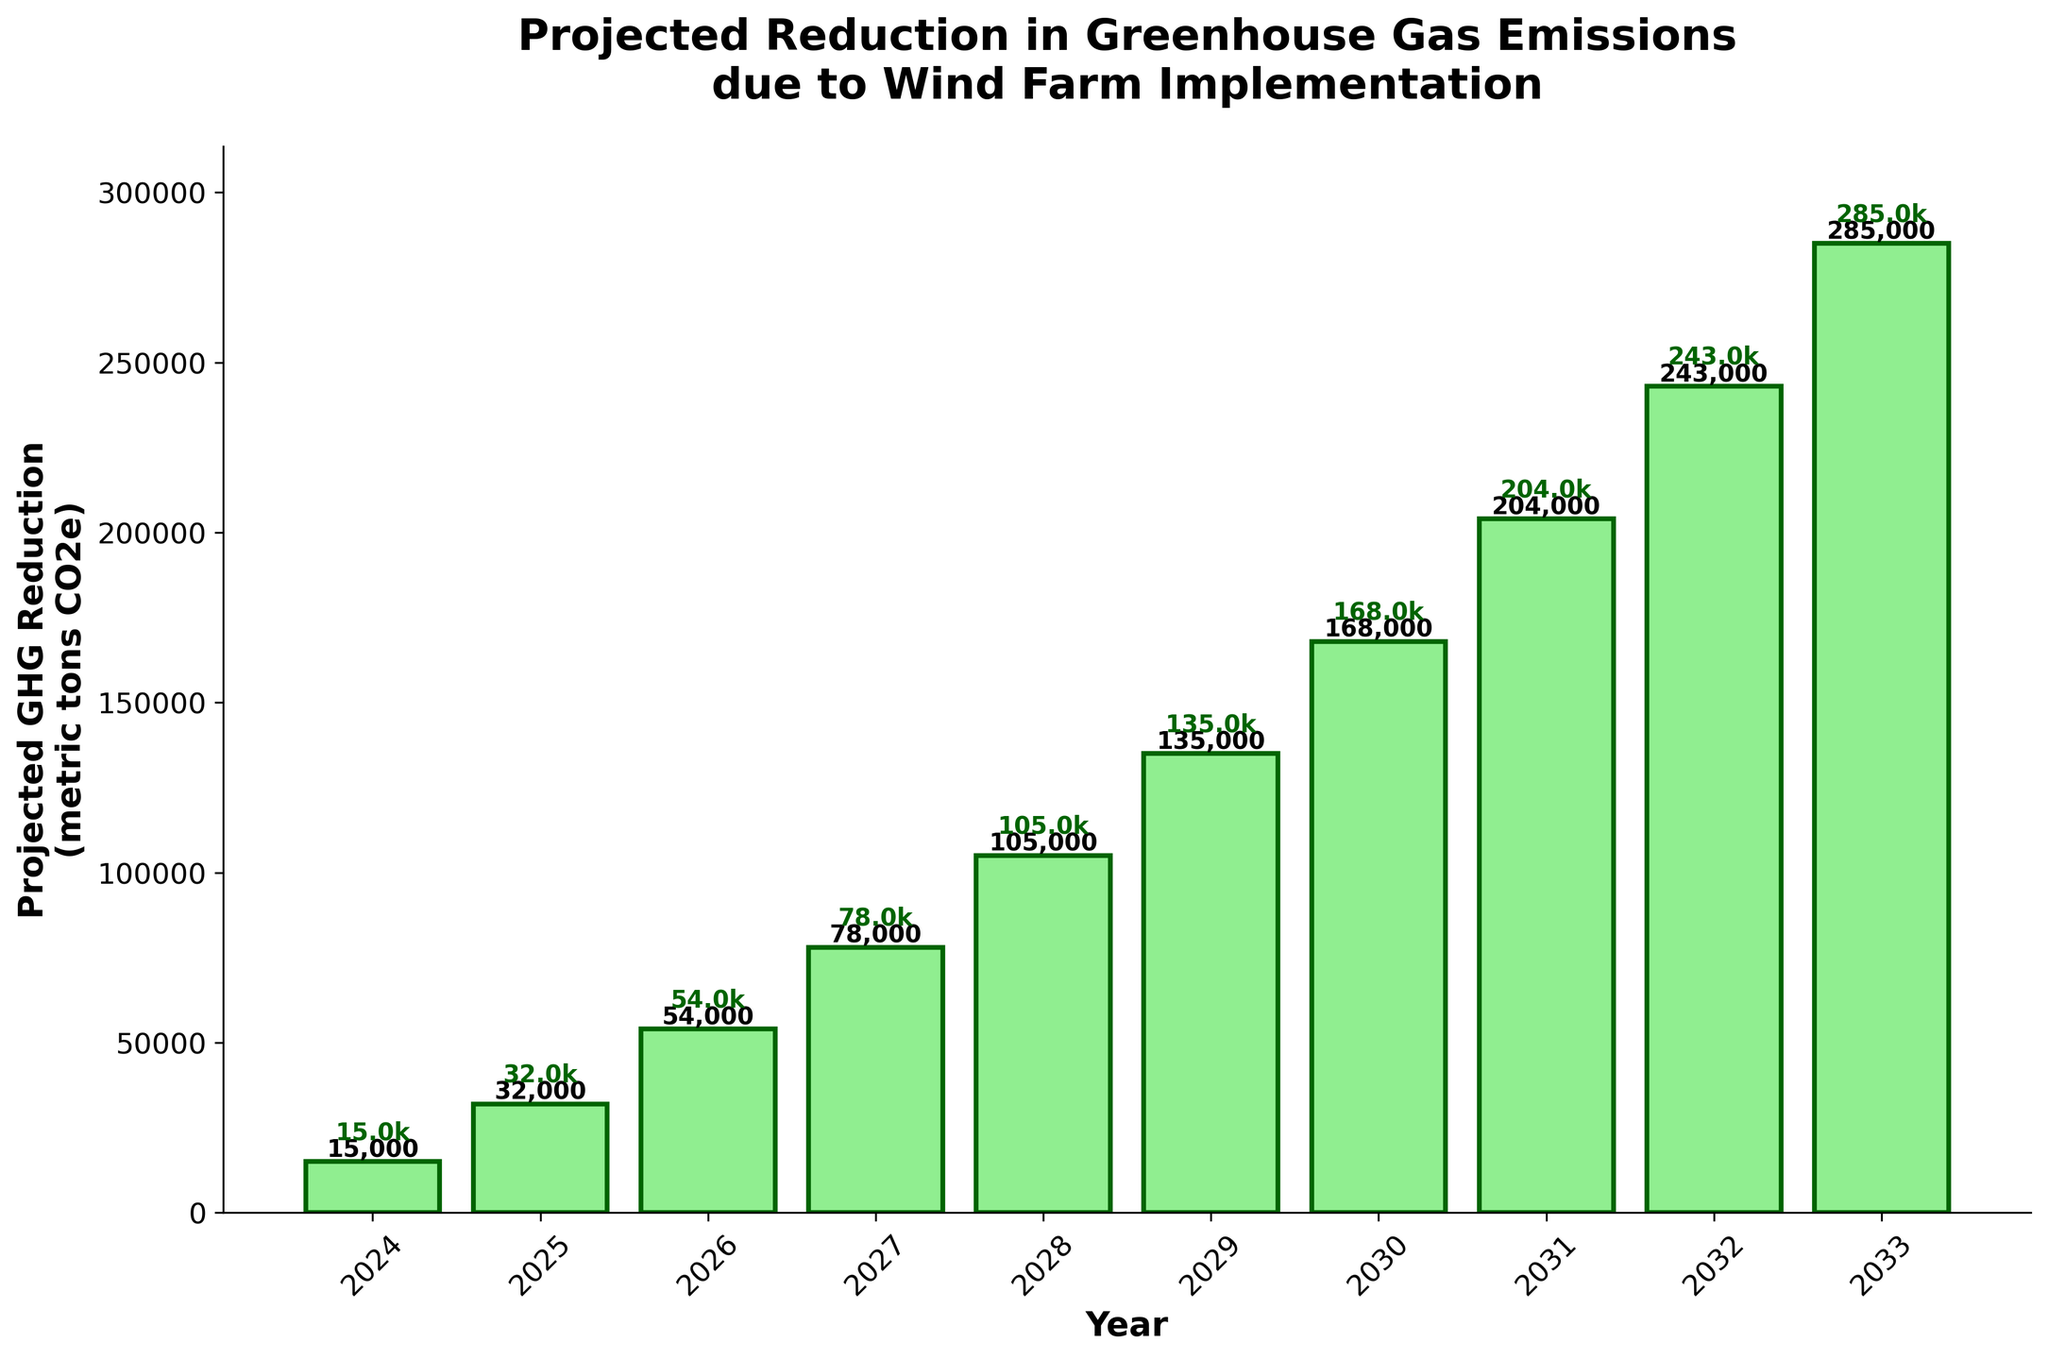What is the projected reduction in GHG emissions for the year 2030? Find the bar corresponding to the year 2030 and read the height of the bar, which represents the projected GHG reduction.
Answer: 168,000 metric tons CO2e Which year has the highest projected reduction in GHG emissions? Look for the tallest bar in the chart and identify the corresponding year at its base.
Answer: 2033 How much more GHG emissions are projected to be reduced in 2028 compared to 2024? Subtract the GHG reduction in 2024 from that in 2028: 105,000 - 15,000.
Answer: 90,000 metric tons CO2e What is the average projected reduction in GHG emissions from 2029 to 2031? Calculate the sum of the reductions in 2029 (135,000), 2030 (168,000), and 2031 (204,000), then divide by 3: (135,000 + 168,000 + 204,000) / 3.
Answer: 169,000 metric tons CO2e How does the projected GHG reduction in 2025 compare to that in 2030? Compare the heights of the bars for 2025 and 2030. The 2025 reduction is 32,000 and the 2030 reduction is 168,000.
Answer: The reduction in 2030 is greater What is the projected GHG reduction for the median year in the dataset? List the years from 2024 to 2033, identify the median year (2028), and find its corresponding GHG reduction.
Answer: 105,000 metric tons CO2e By how much is the projected GHG reduction expected to increase from 2026 to 2027? Subtract the GHG reduction in 2026 from that in 2027: 78,000 - 54,000.
Answer: 24,000 metric tons CO2e What is the percentage increase in projected GHG reductions from 2024 to 2025? Calculate the increase: (32,000 - 15,000), then divide by the 2024 value, and multiply by 100: ((32,000 - 15,000) / 15,000) * 100.
Answer: 113.33% Identify the color used for the bar representing the GHG reduction in the year 2026. Look at the color of the bar for the year 2026.
Answer: Light green 